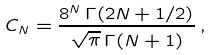<formula> <loc_0><loc_0><loc_500><loc_500>C _ { N } = \frac { 8 ^ { N } \, \Gamma ( 2 N + 1 / 2 ) } { \sqrt { \pi } \, \Gamma ( N + 1 ) } \, ,</formula> 